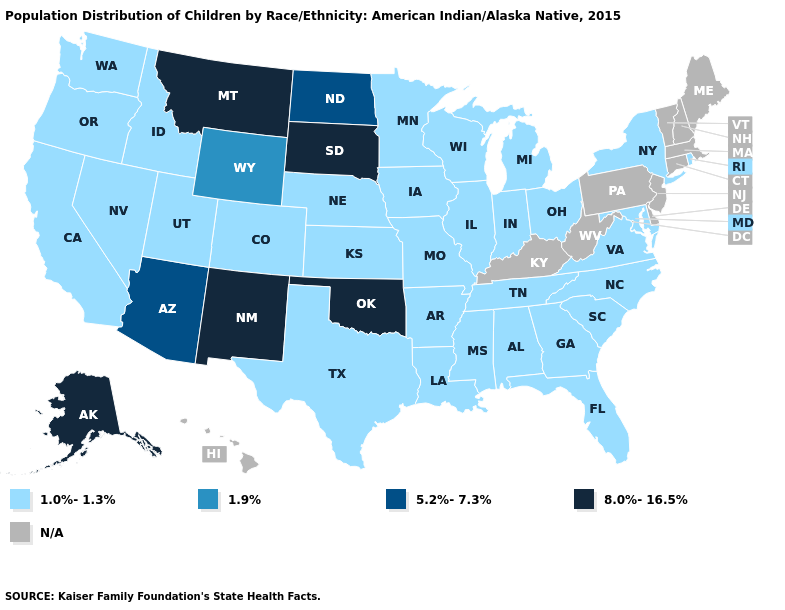Which states hav the highest value in the MidWest?
Concise answer only. South Dakota. Name the states that have a value in the range 1.0%-1.3%?
Concise answer only. Alabama, Arkansas, California, Colorado, Florida, Georgia, Idaho, Illinois, Indiana, Iowa, Kansas, Louisiana, Maryland, Michigan, Minnesota, Mississippi, Missouri, Nebraska, Nevada, New York, North Carolina, Ohio, Oregon, Rhode Island, South Carolina, Tennessee, Texas, Utah, Virginia, Washington, Wisconsin. What is the highest value in states that border Delaware?
Answer briefly. 1.0%-1.3%. What is the value of Hawaii?
Keep it brief. N/A. What is the value of Nevada?
Quick response, please. 1.0%-1.3%. Name the states that have a value in the range 1.9%?
Quick response, please. Wyoming. Does Alaska have the lowest value in the USA?
Write a very short answer. No. What is the value of Utah?
Write a very short answer. 1.0%-1.3%. Does Colorado have the lowest value in the West?
Give a very brief answer. Yes. What is the value of Washington?
Be succinct. 1.0%-1.3%. Name the states that have a value in the range 1.9%?
Keep it brief. Wyoming. Among the states that border Idaho , does Montana have the lowest value?
Concise answer only. No. Name the states that have a value in the range 1.0%-1.3%?
Concise answer only. Alabama, Arkansas, California, Colorado, Florida, Georgia, Idaho, Illinois, Indiana, Iowa, Kansas, Louisiana, Maryland, Michigan, Minnesota, Mississippi, Missouri, Nebraska, Nevada, New York, North Carolina, Ohio, Oregon, Rhode Island, South Carolina, Tennessee, Texas, Utah, Virginia, Washington, Wisconsin. Which states have the highest value in the USA?
Short answer required. Alaska, Montana, New Mexico, Oklahoma, South Dakota. 